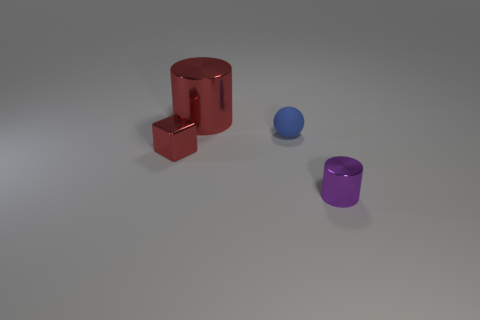Is the material of the small purple thing the same as the cylinder that is behind the purple object?
Provide a short and direct response. Yes. The small matte thing is what color?
Provide a succinct answer. Blue. The shiny cylinder in front of the red thing that is behind the tiny shiny thing that is to the left of the tiny blue object is what color?
Your answer should be compact. Purple. There is a small matte object; is it the same shape as the red thing that is on the left side of the big object?
Make the answer very short. No. There is a thing that is in front of the small blue rubber thing and to the left of the purple shiny cylinder; what is its color?
Ensure brevity in your answer.  Red. Is there a tiny purple metallic thing that has the same shape as the large shiny object?
Provide a succinct answer. Yes. Is the color of the tiny cube the same as the rubber thing?
Offer a terse response. No. Is there a small object that is left of the metallic object that is on the right side of the red metallic cylinder?
Offer a very short reply. Yes. How many things are either tiny red cubes in front of the big red metal cylinder or small shiny things that are behind the tiny purple cylinder?
Offer a very short reply. 1. How many objects are either big rubber spheres or small things left of the blue matte thing?
Provide a short and direct response. 1. 